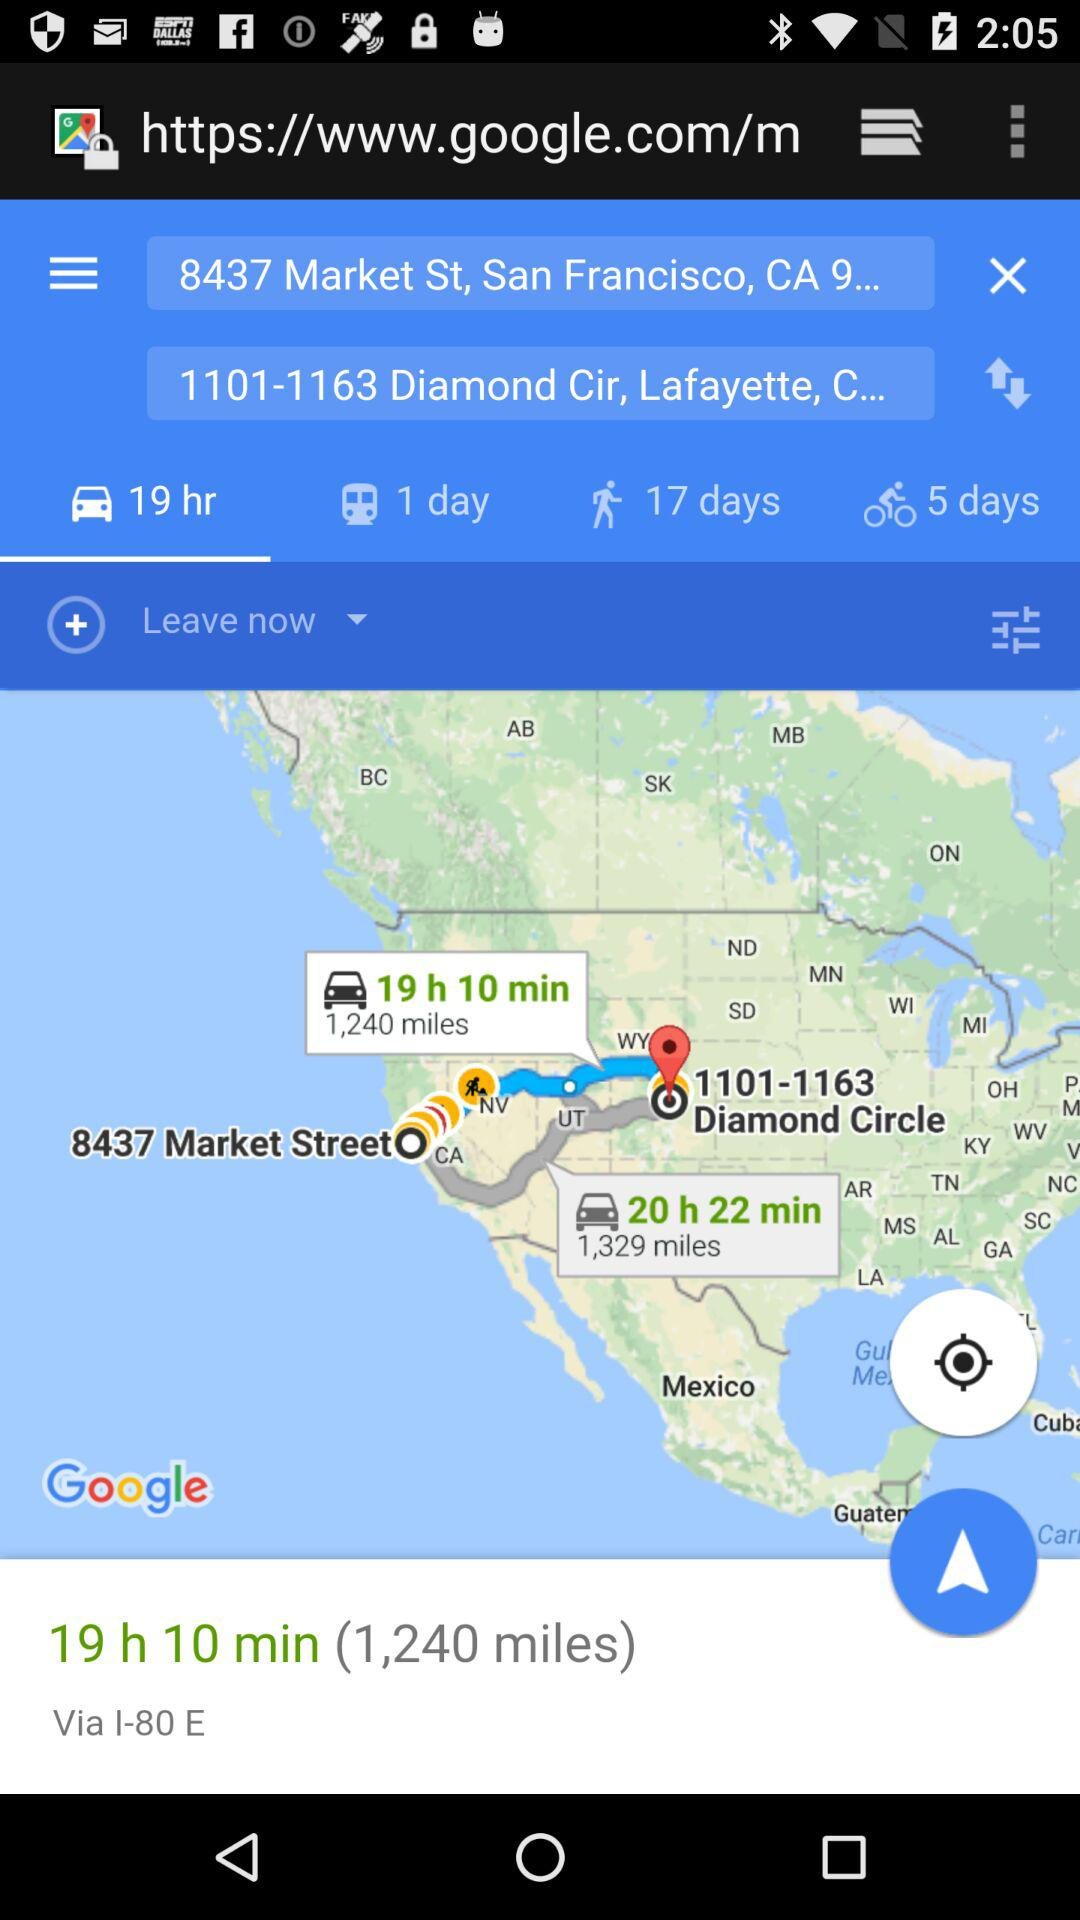What is the given destination location? The location is "1101-1163 Diamond Cir, Lafayette, C...". 